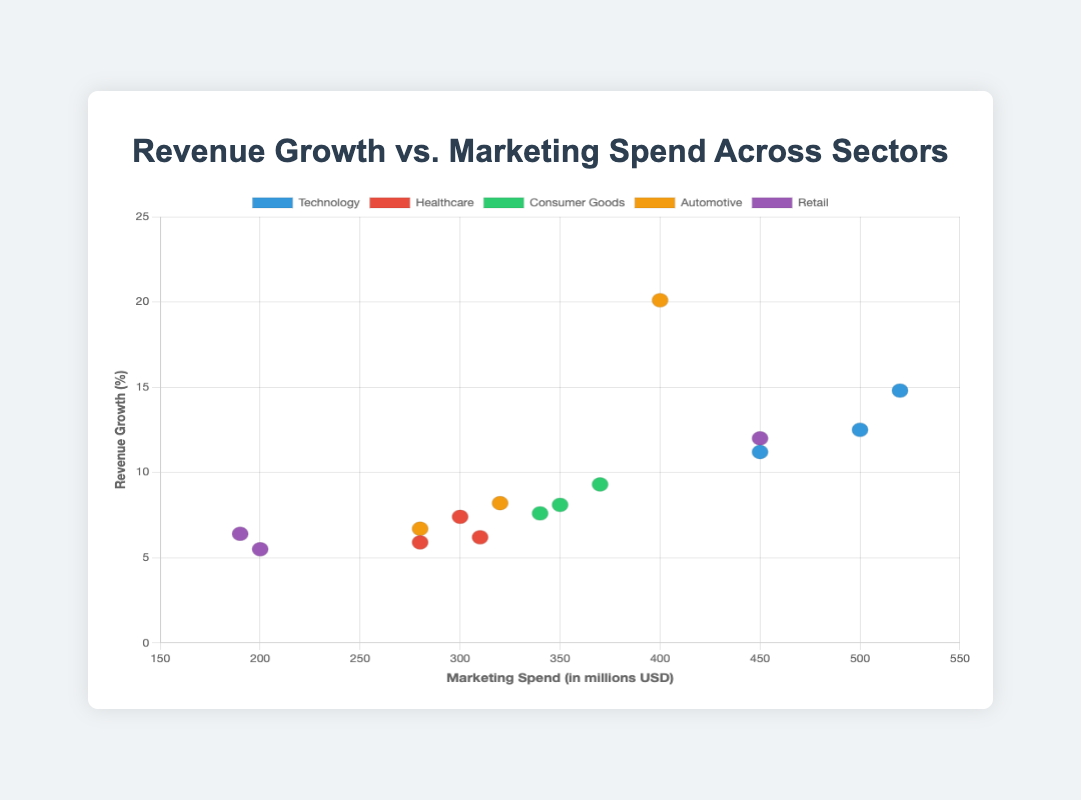What is the title of the scatter plot? The title is displayed at the top of the plot and reads "Revenue Growth vs. Marketing Spend Across Sectors".
Answer: Revenue Growth vs. Marketing Spend Across Sectors What does the x-axis represent? The label on the x-axis indicates that it represents "Marketing Spend (in millions USD)".
Answer: Marketing Spend (in millions USD) How many companies in the Automotive sector have their data plotted on the scatter plot? By looking at the legend and the data points in the Automotive sector color, three companies are observed: Tesla, Toyota, and Ford.
Answer: 3 Which company in the Technology sector has the highest revenue growth? When looking at the data points for the Technology sector and their corresponding labels, Google has the highest revenue growth at 14.8%.
Answer: Google What is the average marketing spend for the companies in the Consumer Goods sector? The Consumer Goods sector includes Procter & Gamble (350), Unilever (340), and Nestlé (370). Summing these values gives 1060, and dividing by 3 gives approximately 353.3.
Answer: 353.3 Which sector has the company with the highest revenue growth, and what is that growth percentage? By examining the data points, Tesla in the Automotive sector has the highest revenue growth at 20.1%.
Answer: Automotive, 20.1% How does Amazon's marketing spend compare to Microsoft’s? Both companies’ data points are examined, and it is observed that Amazon’s marketing spend is 450 million USD, which is the same as Microsoft’s.
Answer: Equal What is the median revenue growth for the Healthcare sector? The Healthcare sector has Pfizer (7.4%), Johnson & Johnson (5.9%), and Merck (6.2%). Arranging these in order gives 5.9%, 6.2%, and 7.4%, so the median value is 6.2%.
Answer: 6.2% What is the total marketing spend for all companies in the Retail sector? Adding up the marketing spend for Walmart (200), Amazon (450), and Costco (190), we get a total of 840 million USD.
Answer: 840 Which company has the lowest marketing spend, and what is the sector it belongs to? The data point for Costco in the Retail sector shows a marketing spend of 190 million USD, which is the lowest.
Answer: Costco, Retail 